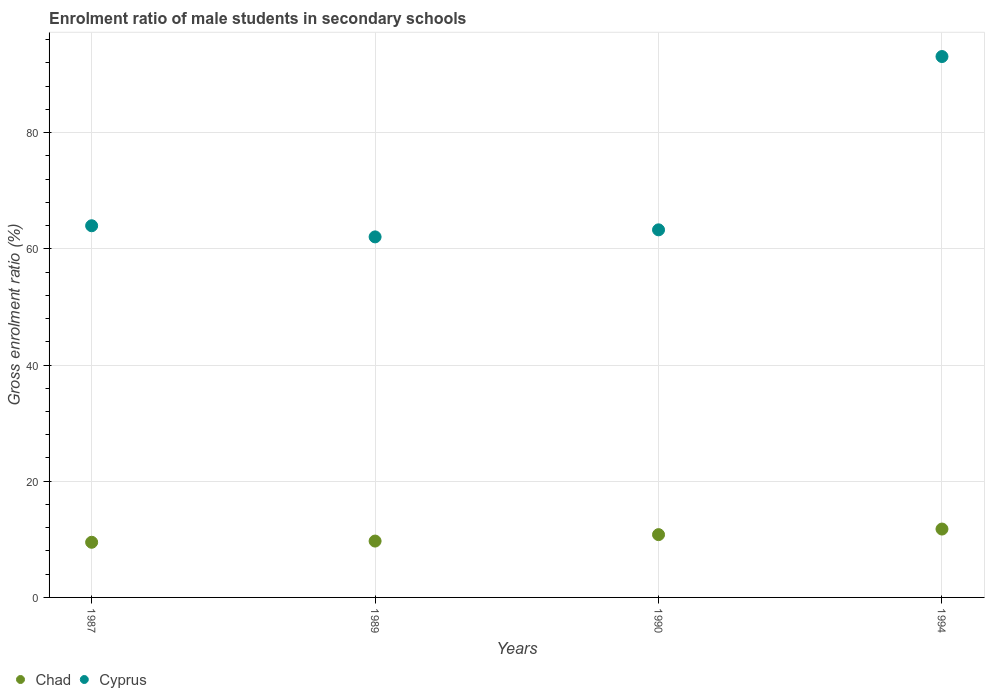How many different coloured dotlines are there?
Provide a short and direct response. 2. Is the number of dotlines equal to the number of legend labels?
Offer a very short reply. Yes. What is the enrolment ratio of male students in secondary schools in Chad in 1990?
Your answer should be very brief. 10.81. Across all years, what is the maximum enrolment ratio of male students in secondary schools in Cyprus?
Offer a terse response. 93.09. Across all years, what is the minimum enrolment ratio of male students in secondary schools in Cyprus?
Your response must be concise. 62.05. In which year was the enrolment ratio of male students in secondary schools in Chad minimum?
Provide a short and direct response. 1987. What is the total enrolment ratio of male students in secondary schools in Chad in the graph?
Your answer should be very brief. 41.77. What is the difference between the enrolment ratio of male students in secondary schools in Cyprus in 1989 and that in 1994?
Provide a short and direct response. -31.04. What is the difference between the enrolment ratio of male students in secondary schools in Cyprus in 1989 and the enrolment ratio of male students in secondary schools in Chad in 1990?
Make the answer very short. 51.24. What is the average enrolment ratio of male students in secondary schools in Chad per year?
Provide a succinct answer. 10.44. In the year 1989, what is the difference between the enrolment ratio of male students in secondary schools in Cyprus and enrolment ratio of male students in secondary schools in Chad?
Provide a succinct answer. 52.35. In how many years, is the enrolment ratio of male students in secondary schools in Chad greater than 84 %?
Provide a succinct answer. 0. What is the ratio of the enrolment ratio of male students in secondary schools in Chad in 1990 to that in 1994?
Provide a short and direct response. 0.92. Is the enrolment ratio of male students in secondary schools in Cyprus in 1987 less than that in 1990?
Provide a short and direct response. No. What is the difference between the highest and the second highest enrolment ratio of male students in secondary schools in Cyprus?
Offer a terse response. 29.12. What is the difference between the highest and the lowest enrolment ratio of male students in secondary schools in Cyprus?
Offer a very short reply. 31.04. In how many years, is the enrolment ratio of male students in secondary schools in Chad greater than the average enrolment ratio of male students in secondary schools in Chad taken over all years?
Your answer should be very brief. 2. Is the enrolment ratio of male students in secondary schools in Chad strictly greater than the enrolment ratio of male students in secondary schools in Cyprus over the years?
Ensure brevity in your answer.  No. How many years are there in the graph?
Offer a terse response. 4. Are the values on the major ticks of Y-axis written in scientific E-notation?
Provide a succinct answer. No. Where does the legend appear in the graph?
Provide a succinct answer. Bottom left. How many legend labels are there?
Ensure brevity in your answer.  2. What is the title of the graph?
Your response must be concise. Enrolment ratio of male students in secondary schools. What is the label or title of the X-axis?
Ensure brevity in your answer.  Years. What is the label or title of the Y-axis?
Provide a short and direct response. Gross enrolment ratio (%). What is the Gross enrolment ratio (%) of Chad in 1987?
Make the answer very short. 9.49. What is the Gross enrolment ratio (%) in Cyprus in 1987?
Your response must be concise. 63.97. What is the Gross enrolment ratio (%) in Chad in 1989?
Provide a succinct answer. 9.7. What is the Gross enrolment ratio (%) in Cyprus in 1989?
Keep it short and to the point. 62.05. What is the Gross enrolment ratio (%) of Chad in 1990?
Keep it short and to the point. 10.81. What is the Gross enrolment ratio (%) of Cyprus in 1990?
Give a very brief answer. 63.26. What is the Gross enrolment ratio (%) in Chad in 1994?
Your response must be concise. 11.77. What is the Gross enrolment ratio (%) in Cyprus in 1994?
Ensure brevity in your answer.  93.09. Across all years, what is the maximum Gross enrolment ratio (%) of Chad?
Make the answer very short. 11.77. Across all years, what is the maximum Gross enrolment ratio (%) of Cyprus?
Your answer should be very brief. 93.09. Across all years, what is the minimum Gross enrolment ratio (%) of Chad?
Give a very brief answer. 9.49. Across all years, what is the minimum Gross enrolment ratio (%) in Cyprus?
Your response must be concise. 62.05. What is the total Gross enrolment ratio (%) of Chad in the graph?
Offer a terse response. 41.77. What is the total Gross enrolment ratio (%) in Cyprus in the graph?
Provide a short and direct response. 282.37. What is the difference between the Gross enrolment ratio (%) in Chad in 1987 and that in 1989?
Offer a terse response. -0.21. What is the difference between the Gross enrolment ratio (%) of Cyprus in 1987 and that in 1989?
Your response must be concise. 1.92. What is the difference between the Gross enrolment ratio (%) of Chad in 1987 and that in 1990?
Your answer should be very brief. -1.31. What is the difference between the Gross enrolment ratio (%) in Cyprus in 1987 and that in 1990?
Make the answer very short. 0.7. What is the difference between the Gross enrolment ratio (%) of Chad in 1987 and that in 1994?
Offer a very short reply. -2.28. What is the difference between the Gross enrolment ratio (%) in Cyprus in 1987 and that in 1994?
Ensure brevity in your answer.  -29.12. What is the difference between the Gross enrolment ratio (%) of Chad in 1989 and that in 1990?
Your response must be concise. -1.11. What is the difference between the Gross enrolment ratio (%) in Cyprus in 1989 and that in 1990?
Ensure brevity in your answer.  -1.21. What is the difference between the Gross enrolment ratio (%) of Chad in 1989 and that in 1994?
Provide a short and direct response. -2.07. What is the difference between the Gross enrolment ratio (%) in Cyprus in 1989 and that in 1994?
Your answer should be very brief. -31.04. What is the difference between the Gross enrolment ratio (%) in Chad in 1990 and that in 1994?
Keep it short and to the point. -0.96. What is the difference between the Gross enrolment ratio (%) of Cyprus in 1990 and that in 1994?
Ensure brevity in your answer.  -29.83. What is the difference between the Gross enrolment ratio (%) in Chad in 1987 and the Gross enrolment ratio (%) in Cyprus in 1989?
Ensure brevity in your answer.  -52.56. What is the difference between the Gross enrolment ratio (%) of Chad in 1987 and the Gross enrolment ratio (%) of Cyprus in 1990?
Offer a terse response. -53.77. What is the difference between the Gross enrolment ratio (%) in Chad in 1987 and the Gross enrolment ratio (%) in Cyprus in 1994?
Keep it short and to the point. -83.6. What is the difference between the Gross enrolment ratio (%) in Chad in 1989 and the Gross enrolment ratio (%) in Cyprus in 1990?
Keep it short and to the point. -53.56. What is the difference between the Gross enrolment ratio (%) in Chad in 1989 and the Gross enrolment ratio (%) in Cyprus in 1994?
Your answer should be very brief. -83.39. What is the difference between the Gross enrolment ratio (%) in Chad in 1990 and the Gross enrolment ratio (%) in Cyprus in 1994?
Your response must be concise. -82.28. What is the average Gross enrolment ratio (%) in Chad per year?
Give a very brief answer. 10.44. What is the average Gross enrolment ratio (%) of Cyprus per year?
Provide a succinct answer. 70.59. In the year 1987, what is the difference between the Gross enrolment ratio (%) in Chad and Gross enrolment ratio (%) in Cyprus?
Offer a terse response. -54.47. In the year 1989, what is the difference between the Gross enrolment ratio (%) in Chad and Gross enrolment ratio (%) in Cyprus?
Provide a succinct answer. -52.35. In the year 1990, what is the difference between the Gross enrolment ratio (%) of Chad and Gross enrolment ratio (%) of Cyprus?
Offer a very short reply. -52.46. In the year 1994, what is the difference between the Gross enrolment ratio (%) of Chad and Gross enrolment ratio (%) of Cyprus?
Provide a short and direct response. -81.32. What is the ratio of the Gross enrolment ratio (%) in Chad in 1987 to that in 1989?
Your response must be concise. 0.98. What is the ratio of the Gross enrolment ratio (%) of Cyprus in 1987 to that in 1989?
Your answer should be compact. 1.03. What is the ratio of the Gross enrolment ratio (%) in Chad in 1987 to that in 1990?
Offer a very short reply. 0.88. What is the ratio of the Gross enrolment ratio (%) in Cyprus in 1987 to that in 1990?
Your answer should be very brief. 1.01. What is the ratio of the Gross enrolment ratio (%) in Chad in 1987 to that in 1994?
Offer a terse response. 0.81. What is the ratio of the Gross enrolment ratio (%) of Cyprus in 1987 to that in 1994?
Make the answer very short. 0.69. What is the ratio of the Gross enrolment ratio (%) of Chad in 1989 to that in 1990?
Offer a very short reply. 0.9. What is the ratio of the Gross enrolment ratio (%) in Cyprus in 1989 to that in 1990?
Offer a terse response. 0.98. What is the ratio of the Gross enrolment ratio (%) of Chad in 1989 to that in 1994?
Ensure brevity in your answer.  0.82. What is the ratio of the Gross enrolment ratio (%) in Cyprus in 1989 to that in 1994?
Ensure brevity in your answer.  0.67. What is the ratio of the Gross enrolment ratio (%) in Chad in 1990 to that in 1994?
Offer a very short reply. 0.92. What is the ratio of the Gross enrolment ratio (%) of Cyprus in 1990 to that in 1994?
Your answer should be compact. 0.68. What is the difference between the highest and the second highest Gross enrolment ratio (%) in Chad?
Offer a very short reply. 0.96. What is the difference between the highest and the second highest Gross enrolment ratio (%) of Cyprus?
Make the answer very short. 29.12. What is the difference between the highest and the lowest Gross enrolment ratio (%) of Chad?
Your answer should be compact. 2.28. What is the difference between the highest and the lowest Gross enrolment ratio (%) of Cyprus?
Your answer should be very brief. 31.04. 